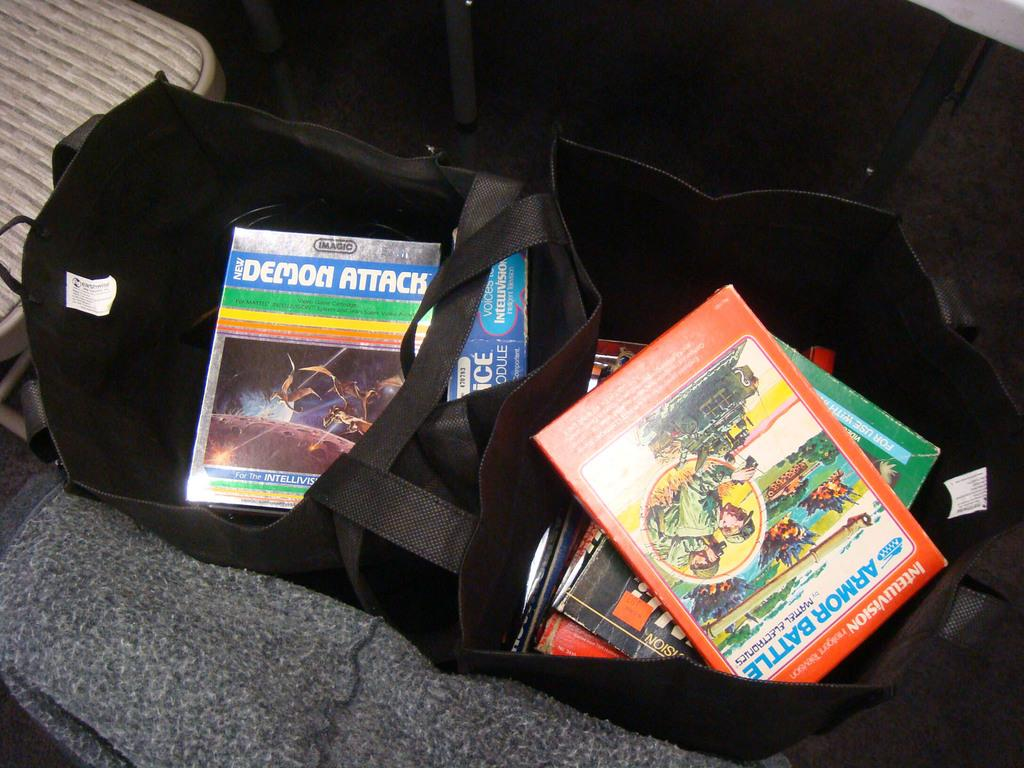What is the color of the bag in the image? The bag in the image is black. What objects are placed on the mat in the image? There are books placed on a mat in the image. Where is the table located in the image? The table is on the left side of the image. What type of tank is visible in the image? There is no tank present in the image. What impulse might have led to the arrangement of the books on the mat? The image does not provide information about the impulse that led to the arrangement of the books on the mat. 